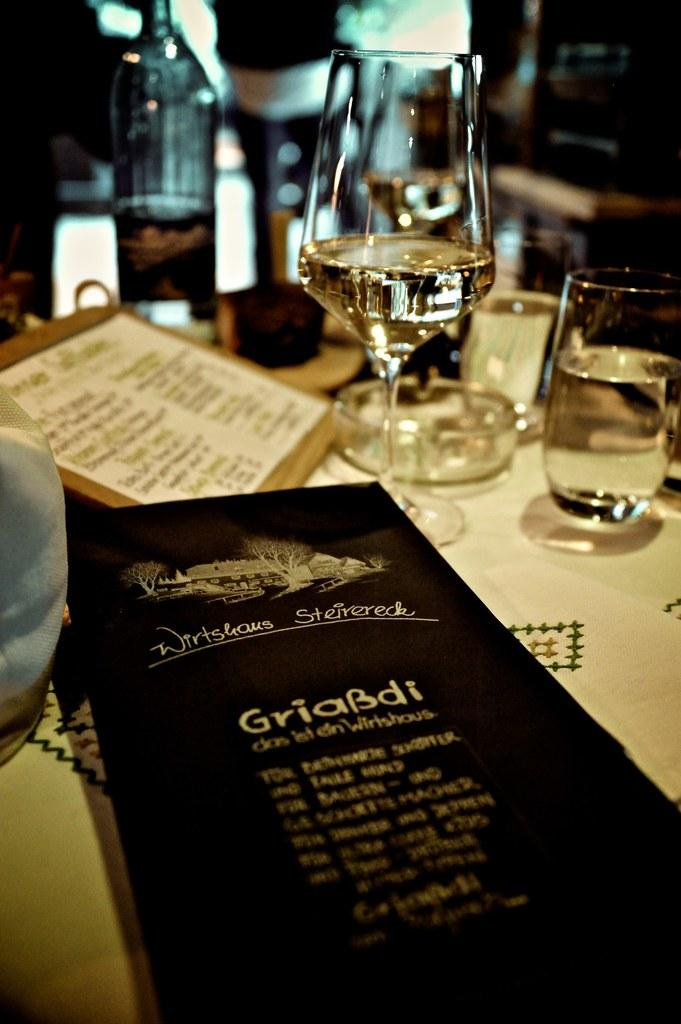What type of furniture is present in the image? There is a table in the image. What objects are placed on the table? Glasses, ashtrays, and papers are placed on the table. Can you describe the background of the image? There is a bottle in the background of the image. What rate does the dime on the table pay in the image? There is no dime present in the image, so it is not possible to determine the rate it pays. 